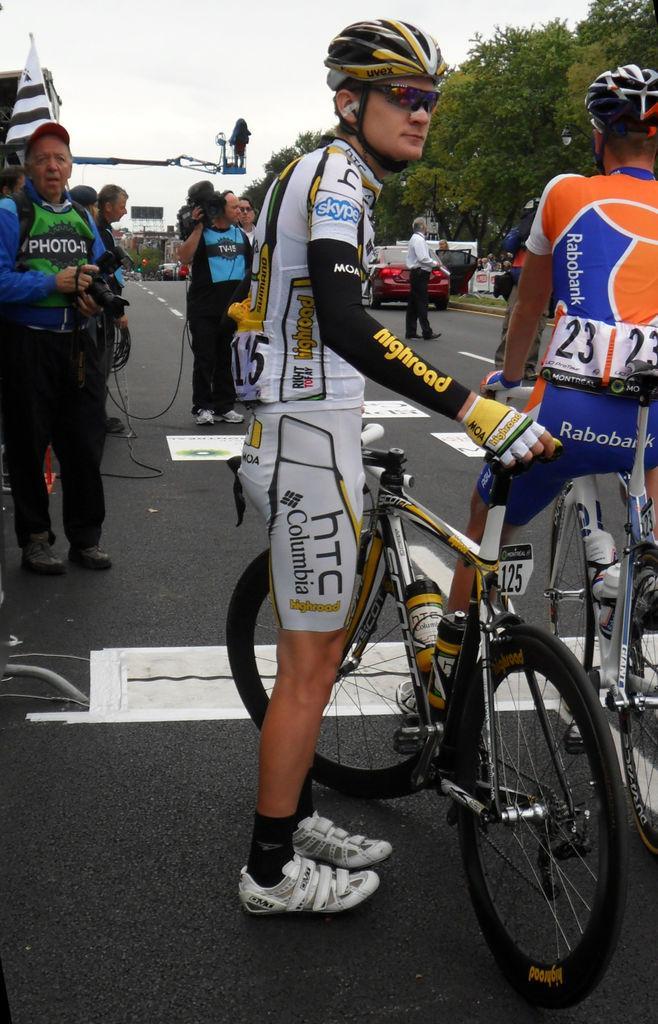Can you describe this image briefly? In this image i can two men wearing helmet and glasses on the road. This man is holding a bicycle and the other man is sitting on the bicycle. There are other vehicles on the road. Here we have a man holding a camera and standing on the road. Here we have trees and an open sky. 